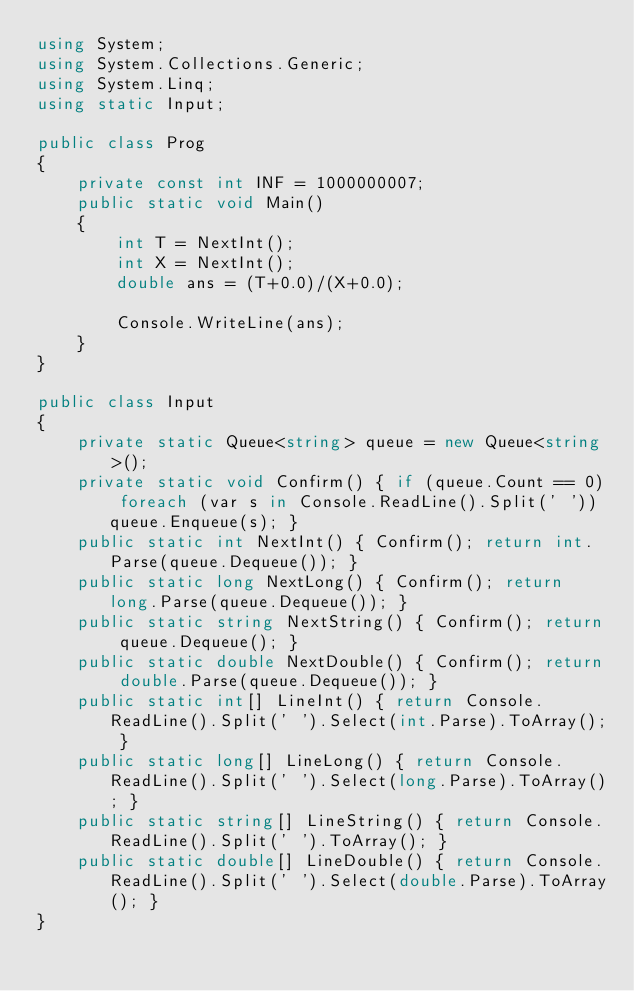Convert code to text. <code><loc_0><loc_0><loc_500><loc_500><_C#_>using System;
using System.Collections.Generic;
using System.Linq;
using static Input;

public class Prog
{
    private const int INF = 1000000007;
    public static void Main()
    {
        int T = NextInt();
        int X = NextInt();
        double ans = (T+0.0)/(X+0.0);

        Console.WriteLine(ans);
    }
}

public class Input
{
    private static Queue<string> queue = new Queue<string>();
    private static void Confirm() { if (queue.Count == 0) foreach (var s in Console.ReadLine().Split(' ')) queue.Enqueue(s); }
    public static int NextInt() { Confirm(); return int.Parse(queue.Dequeue()); }
    public static long NextLong() { Confirm(); return long.Parse(queue.Dequeue()); }
    public static string NextString() { Confirm(); return queue.Dequeue(); }
    public static double NextDouble() { Confirm(); return double.Parse(queue.Dequeue()); }
    public static int[] LineInt() { return Console.ReadLine().Split(' ').Select(int.Parse).ToArray(); }
    public static long[] LineLong() { return Console.ReadLine().Split(' ').Select(long.Parse).ToArray(); }
    public static string[] LineString() { return Console.ReadLine().Split(' ').ToArray(); }
    public static double[] LineDouble() { return Console.ReadLine().Split(' ').Select(double.Parse).ToArray(); }
}
</code> 